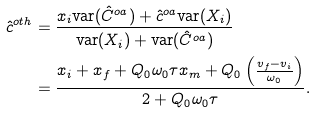<formula> <loc_0><loc_0><loc_500><loc_500>\hat { c } ^ { o t h } & = \frac { x _ { i } \text {var} ( \hat { C } ^ { o a } ) + \hat { c } ^ { o a } \text {var} ( X _ { i } ) } { \text {var} ( X _ { i } ) + \text {var} ( \hat { C } ^ { o a } ) } \\ & = \frac { x _ { i } + x _ { f } + Q _ { 0 } \omega _ { 0 } \tau x _ { m } + Q _ { 0 } \left ( \frac { v _ { f } - v _ { i } } { \omega _ { 0 } } \right ) } { 2 + Q _ { 0 } \omega _ { 0 } \tau } .</formula> 